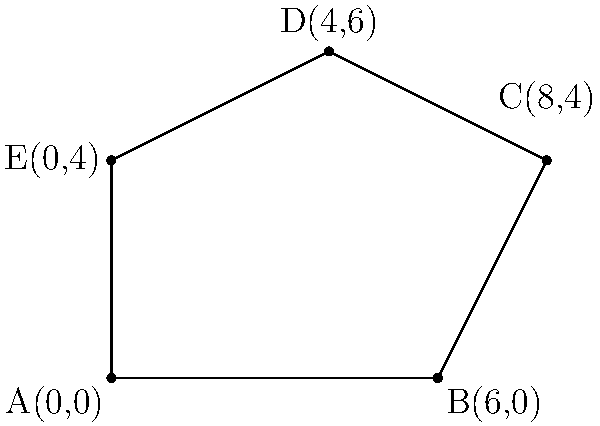As an occupational therapist, you're designing a new horse therapy pasture. The proposed pasture is a polygon with vertices A(0,0), B(6,0), C(8,4), D(4,6), and E(0,4). Calculate the area of this pasture using coordinate geometry methods. To find the area of the polygonal pasture, we can use the Shoelace formula (also known as the surveyor's formula). The steps are as follows:

1) First, list the coordinates in order, repeating the first coordinate at the end:
   (0,0), (6,0), (8,4), (4,6), (0,4), (0,0)

2) Multiply each x-coordinate by the y-coordinate of the next point:
   $0 \cdot 0 + 6 \cdot 4 + 8 \cdot 6 + 4 \cdot 4 + 0 \cdot 0 = 0 + 24 + 48 + 16 + 0 = 88$

3) Multiply each y-coordinate by the x-coordinate of the next point:
   $0 \cdot 6 + 0 \cdot 8 + 4 \cdot 4 + 6 \cdot 0 + 4 \cdot 0 = 0 + 0 + 16 + 0 + 0 = 16$

4) Subtract the result of step 3 from the result of step 2:
   $88 - 16 = 72$

5) Divide this result by 2 to get the area:
   $\frac{72}{2} = 36$

Therefore, the area of the pasture is 36 square units.
Answer: 36 square units 